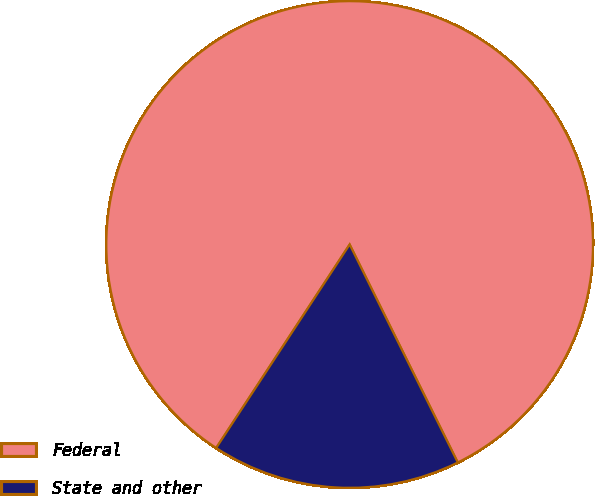<chart> <loc_0><loc_0><loc_500><loc_500><pie_chart><fcel>Federal<fcel>State and other<nl><fcel>83.43%<fcel>16.57%<nl></chart> 